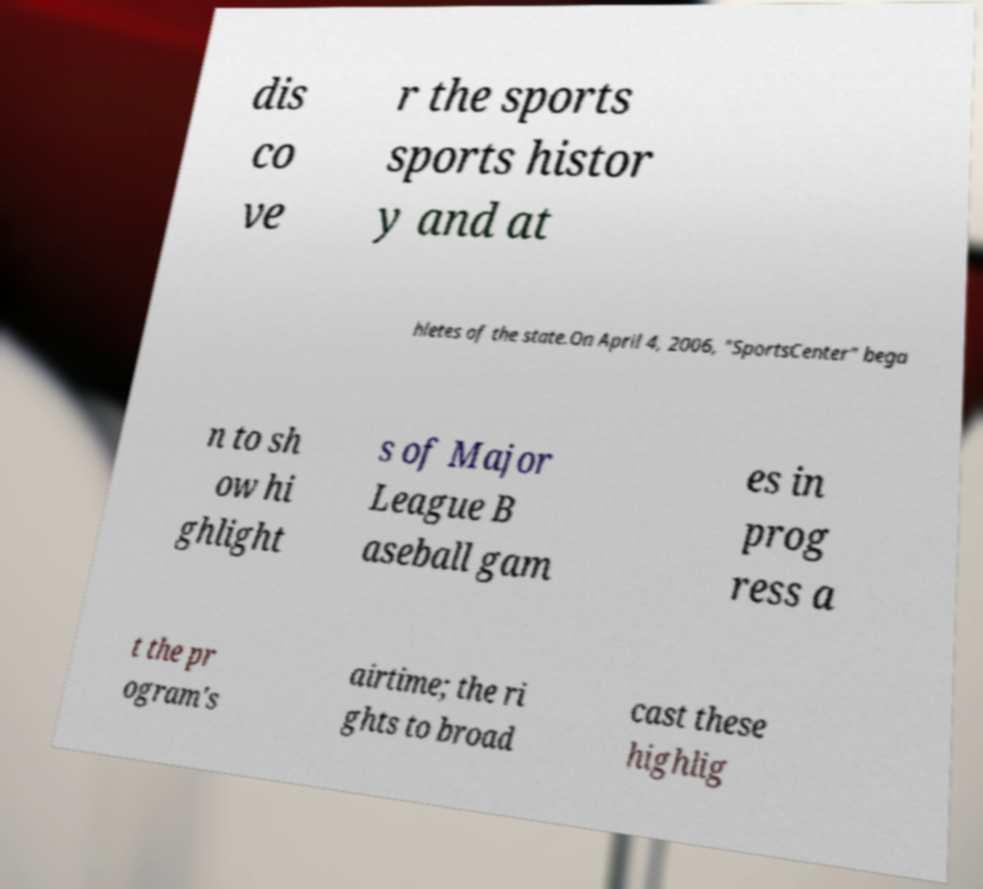I need the written content from this picture converted into text. Can you do that? dis co ve r the sports sports histor y and at hletes of the state.On April 4, 2006, "SportsCenter" bega n to sh ow hi ghlight s of Major League B aseball gam es in prog ress a t the pr ogram's airtime; the ri ghts to broad cast these highlig 